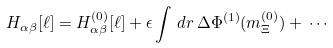Convert formula to latex. <formula><loc_0><loc_0><loc_500><loc_500>H _ { \alpha \beta } [ \ell ] = H _ { \alpha \beta } ^ { ( 0 ) } [ \ell ] + \epsilon \int \, d { r } \, \Delta \Phi ^ { ( 1 ) } ( m _ { \Xi } ^ { ( 0 ) } ) + \, \cdots</formula> 